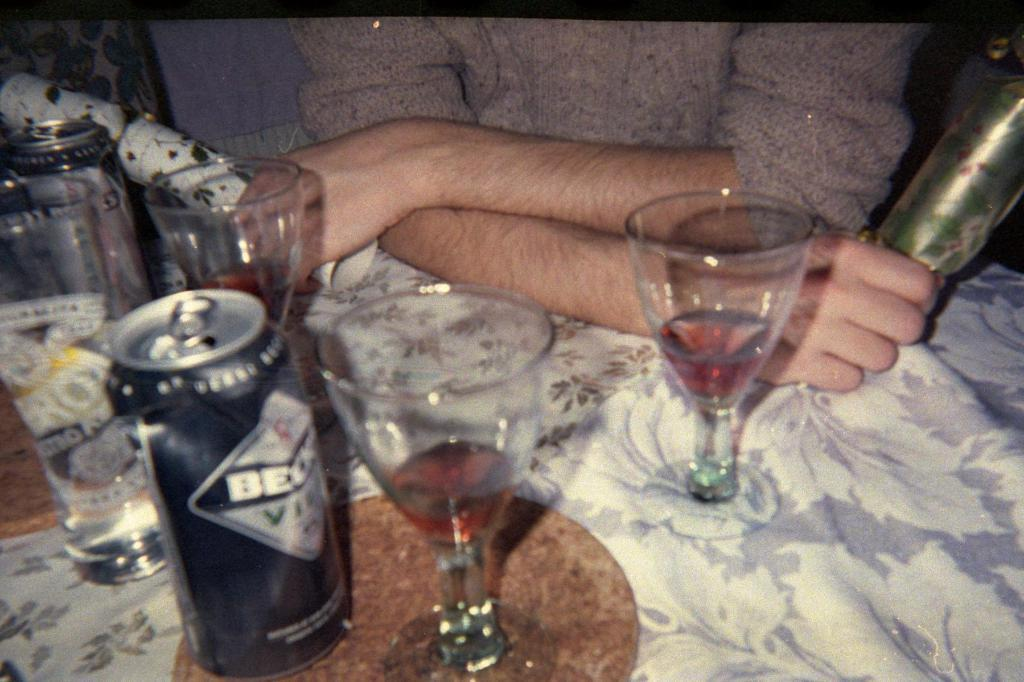What is present on the table in the image? The table is covered with a tablecloth, and there are different objects on the table. Can you describe the person in the image? There is a person sitting in the image, and they are holding some objects. What is the surface of the table covered with? The surface of the table is covered with a tablecloth, and there are objects on it. Where is the goat in the image? There is no goat present in the image. What type of van is parked near the table in the image? There is no van present in the image. 